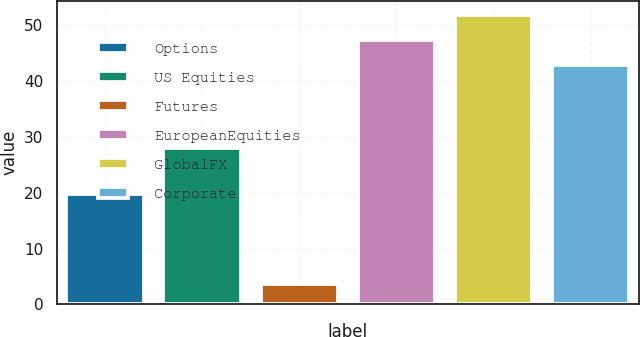Convert chart. <chart><loc_0><loc_0><loc_500><loc_500><bar_chart><fcel>Options<fcel>US Equities<fcel>Futures<fcel>EuropeanEquities<fcel>GlobalFX<fcel>Corporate<nl><fcel>19.7<fcel>28<fcel>3.6<fcel>47.3<fcel>51.7<fcel>42.9<nl></chart> 